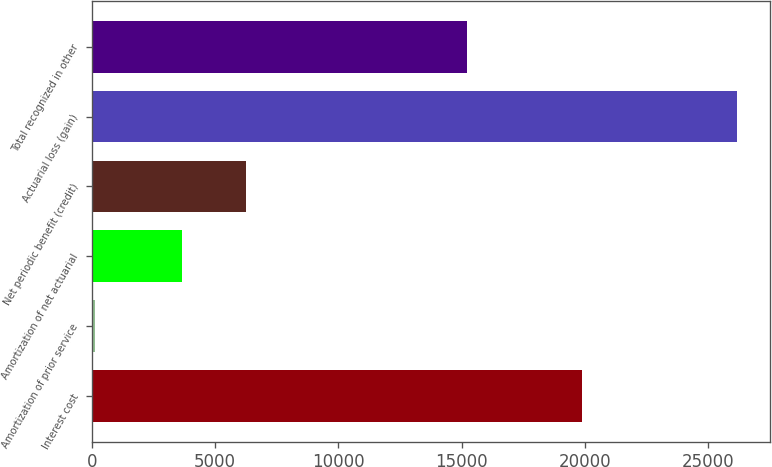<chart> <loc_0><loc_0><loc_500><loc_500><bar_chart><fcel>Interest cost<fcel>Amortization of prior service<fcel>Amortization of net actuarial<fcel>Net periodic benefit (credit)<fcel>Actuarial loss (gain)<fcel>Total recognized in other<nl><fcel>19888<fcel>133<fcel>3646<fcel>6251.1<fcel>26184<fcel>15195<nl></chart> 